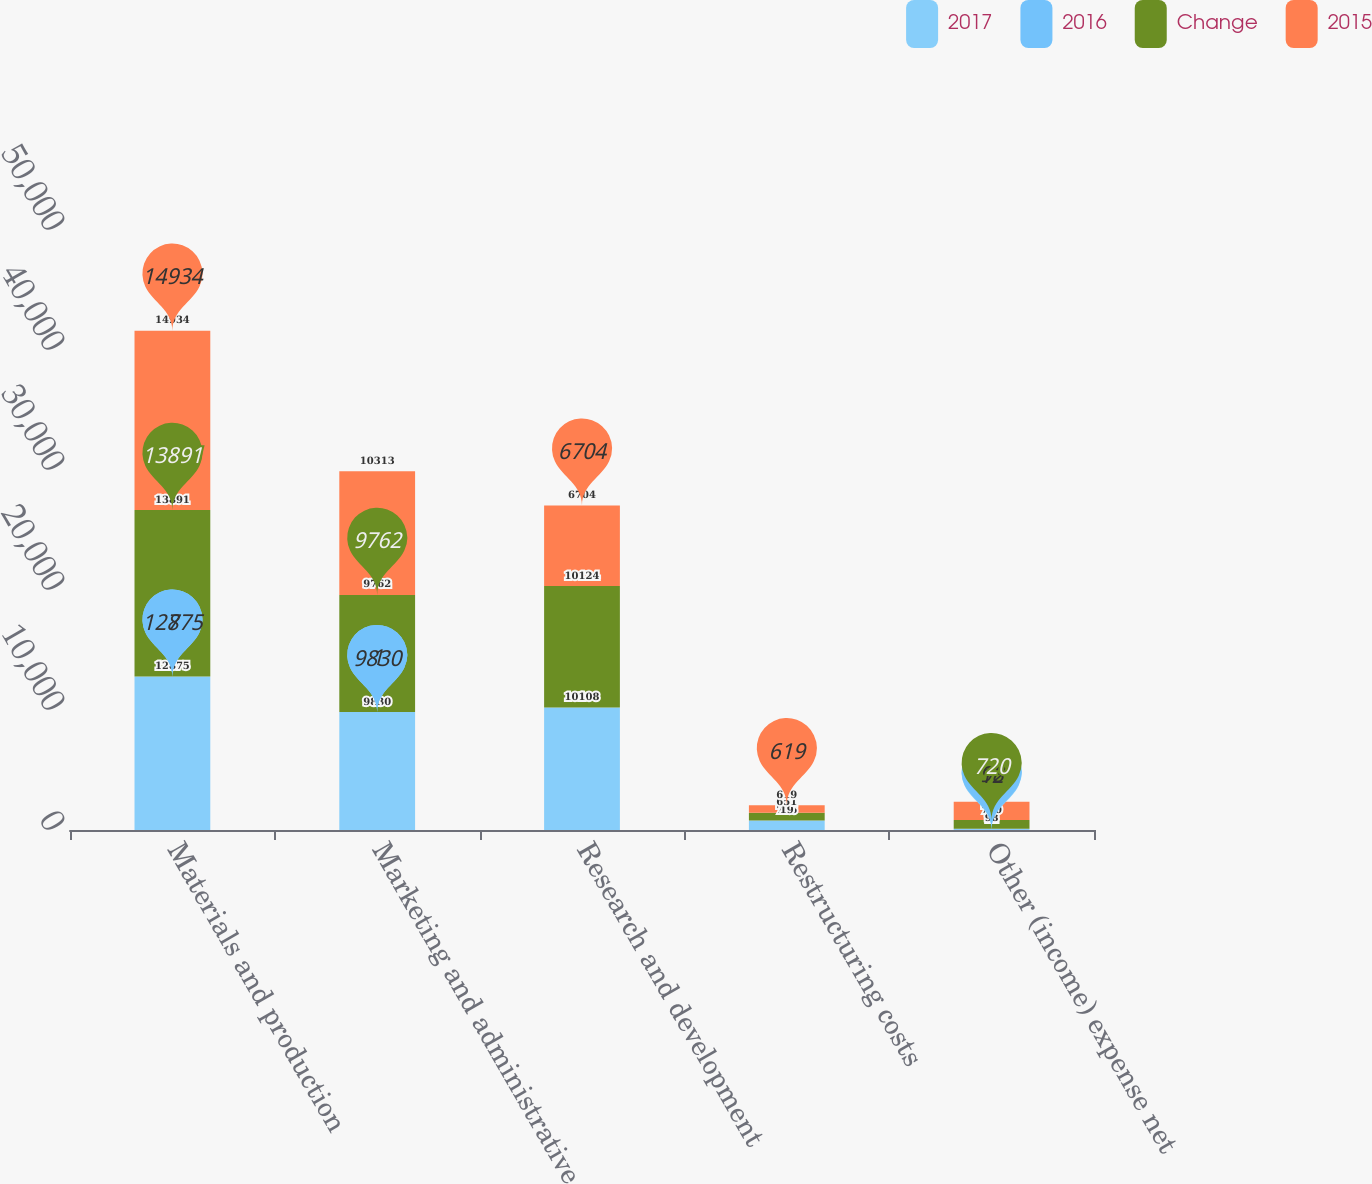<chart> <loc_0><loc_0><loc_500><loc_500><stacked_bar_chart><ecel><fcel>Materials and production<fcel>Marketing and administrative<fcel>Research and development<fcel>Restructuring costs<fcel>Other (income) expense net<nl><fcel>2017<fcel>12775<fcel>9830<fcel>10208<fcel>776<fcel>12<nl><fcel>2016<fcel>8<fcel>1<fcel>1<fcel>19<fcel>98<nl><fcel>Change<fcel>13891<fcel>9762<fcel>10124<fcel>651<fcel>720<nl><fcel>2015<fcel>14934<fcel>10313<fcel>6704<fcel>619<fcel>1527<nl></chart> 